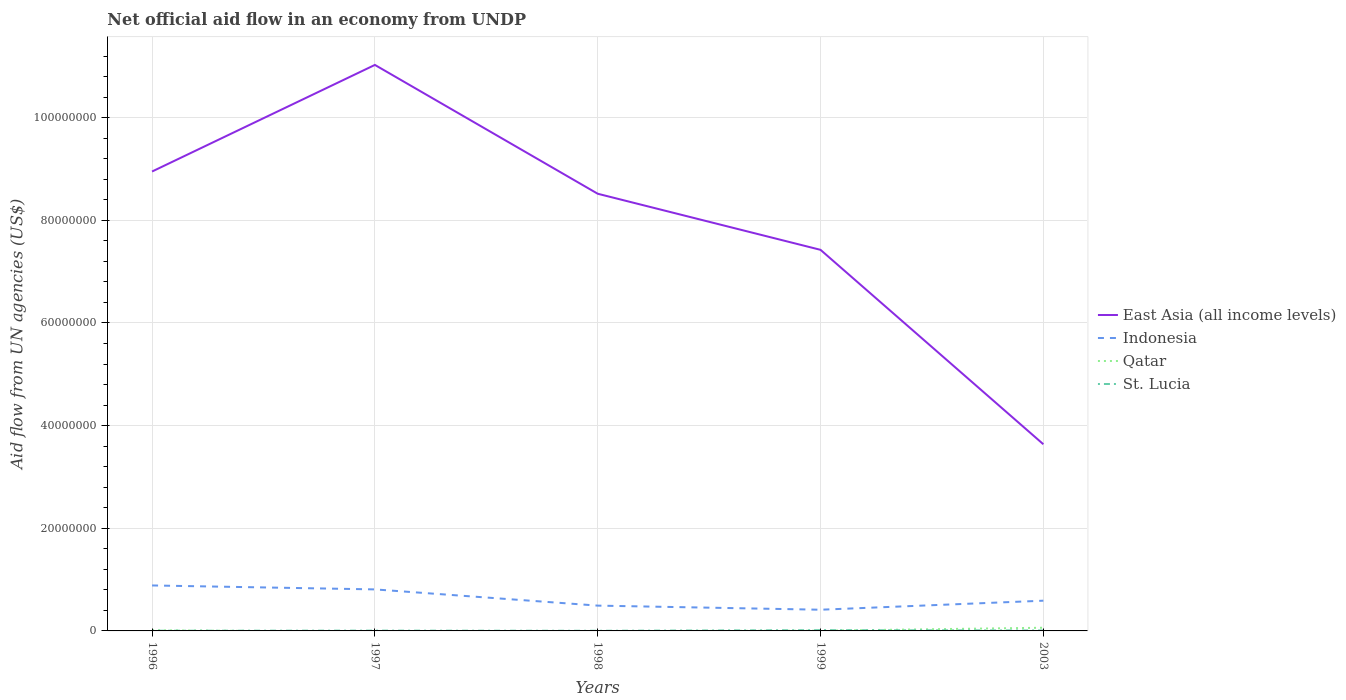Is the number of lines equal to the number of legend labels?
Provide a succinct answer. No. Across all years, what is the maximum net official aid flow in East Asia (all income levels)?
Give a very brief answer. 3.64e+07. What is the total net official aid flow in St. Lucia in the graph?
Offer a very short reply. 10000. What is the difference between the highest and the second highest net official aid flow in Qatar?
Keep it short and to the point. 6.20e+05. What is the difference between the highest and the lowest net official aid flow in Qatar?
Provide a succinct answer. 1. Is the net official aid flow in Indonesia strictly greater than the net official aid flow in St. Lucia over the years?
Offer a terse response. No. How many years are there in the graph?
Your answer should be very brief. 5. What is the difference between two consecutive major ticks on the Y-axis?
Your answer should be compact. 2.00e+07. Does the graph contain any zero values?
Make the answer very short. Yes. Where does the legend appear in the graph?
Provide a short and direct response. Center right. What is the title of the graph?
Offer a terse response. Net official aid flow in an economy from UNDP. Does "New Zealand" appear as one of the legend labels in the graph?
Keep it short and to the point. No. What is the label or title of the Y-axis?
Provide a short and direct response. Aid flow from UN agencies (US$). What is the Aid flow from UN agencies (US$) of East Asia (all income levels) in 1996?
Offer a very short reply. 8.95e+07. What is the Aid flow from UN agencies (US$) of Indonesia in 1996?
Your answer should be compact. 8.86e+06. What is the Aid flow from UN agencies (US$) of Qatar in 1996?
Make the answer very short. 1.30e+05. What is the Aid flow from UN agencies (US$) in East Asia (all income levels) in 1997?
Provide a short and direct response. 1.10e+08. What is the Aid flow from UN agencies (US$) of Indonesia in 1997?
Provide a succinct answer. 8.09e+06. What is the Aid flow from UN agencies (US$) in St. Lucia in 1997?
Ensure brevity in your answer.  6.00e+04. What is the Aid flow from UN agencies (US$) in East Asia (all income levels) in 1998?
Your answer should be compact. 8.52e+07. What is the Aid flow from UN agencies (US$) in Indonesia in 1998?
Give a very brief answer. 4.93e+06. What is the Aid flow from UN agencies (US$) of Qatar in 1998?
Your answer should be very brief. 0. What is the Aid flow from UN agencies (US$) of St. Lucia in 1998?
Your answer should be compact. 3.00e+04. What is the Aid flow from UN agencies (US$) in East Asia (all income levels) in 1999?
Make the answer very short. 7.42e+07. What is the Aid flow from UN agencies (US$) in Indonesia in 1999?
Offer a terse response. 4.13e+06. What is the Aid flow from UN agencies (US$) in St. Lucia in 1999?
Your response must be concise. 1.50e+05. What is the Aid flow from UN agencies (US$) of East Asia (all income levels) in 2003?
Provide a succinct answer. 3.64e+07. What is the Aid flow from UN agencies (US$) of Indonesia in 2003?
Ensure brevity in your answer.  5.89e+06. What is the Aid flow from UN agencies (US$) in Qatar in 2003?
Provide a short and direct response. 6.20e+05. Across all years, what is the maximum Aid flow from UN agencies (US$) in East Asia (all income levels)?
Offer a terse response. 1.10e+08. Across all years, what is the maximum Aid flow from UN agencies (US$) of Indonesia?
Ensure brevity in your answer.  8.86e+06. Across all years, what is the maximum Aid flow from UN agencies (US$) in Qatar?
Keep it short and to the point. 6.20e+05. Across all years, what is the minimum Aid flow from UN agencies (US$) of East Asia (all income levels)?
Your response must be concise. 3.64e+07. Across all years, what is the minimum Aid flow from UN agencies (US$) in Indonesia?
Your response must be concise. 4.13e+06. Across all years, what is the minimum Aid flow from UN agencies (US$) in St. Lucia?
Provide a short and direct response. 3.00e+04. What is the total Aid flow from UN agencies (US$) of East Asia (all income levels) in the graph?
Your answer should be compact. 3.96e+08. What is the total Aid flow from UN agencies (US$) in Indonesia in the graph?
Offer a terse response. 3.19e+07. What is the total Aid flow from UN agencies (US$) of Qatar in the graph?
Your response must be concise. 7.90e+05. What is the difference between the Aid flow from UN agencies (US$) in East Asia (all income levels) in 1996 and that in 1997?
Your response must be concise. -2.08e+07. What is the difference between the Aid flow from UN agencies (US$) in Indonesia in 1996 and that in 1997?
Your answer should be very brief. 7.70e+05. What is the difference between the Aid flow from UN agencies (US$) in East Asia (all income levels) in 1996 and that in 1998?
Your answer should be very brief. 4.33e+06. What is the difference between the Aid flow from UN agencies (US$) in Indonesia in 1996 and that in 1998?
Your answer should be compact. 3.93e+06. What is the difference between the Aid flow from UN agencies (US$) of St. Lucia in 1996 and that in 1998?
Ensure brevity in your answer.  10000. What is the difference between the Aid flow from UN agencies (US$) of East Asia (all income levels) in 1996 and that in 1999?
Your answer should be compact. 1.53e+07. What is the difference between the Aid flow from UN agencies (US$) of Indonesia in 1996 and that in 1999?
Provide a short and direct response. 4.73e+06. What is the difference between the Aid flow from UN agencies (US$) in St. Lucia in 1996 and that in 1999?
Your response must be concise. -1.10e+05. What is the difference between the Aid flow from UN agencies (US$) of East Asia (all income levels) in 1996 and that in 2003?
Your response must be concise. 5.31e+07. What is the difference between the Aid flow from UN agencies (US$) of Indonesia in 1996 and that in 2003?
Ensure brevity in your answer.  2.97e+06. What is the difference between the Aid flow from UN agencies (US$) of Qatar in 1996 and that in 2003?
Provide a short and direct response. -4.90e+05. What is the difference between the Aid flow from UN agencies (US$) of East Asia (all income levels) in 1997 and that in 1998?
Offer a terse response. 2.51e+07. What is the difference between the Aid flow from UN agencies (US$) in Indonesia in 1997 and that in 1998?
Your response must be concise. 3.16e+06. What is the difference between the Aid flow from UN agencies (US$) of St. Lucia in 1997 and that in 1998?
Keep it short and to the point. 3.00e+04. What is the difference between the Aid flow from UN agencies (US$) in East Asia (all income levels) in 1997 and that in 1999?
Keep it short and to the point. 3.60e+07. What is the difference between the Aid flow from UN agencies (US$) of Indonesia in 1997 and that in 1999?
Offer a terse response. 3.96e+06. What is the difference between the Aid flow from UN agencies (US$) of East Asia (all income levels) in 1997 and that in 2003?
Give a very brief answer. 7.39e+07. What is the difference between the Aid flow from UN agencies (US$) in Indonesia in 1997 and that in 2003?
Give a very brief answer. 2.20e+06. What is the difference between the Aid flow from UN agencies (US$) in St. Lucia in 1997 and that in 2003?
Your answer should be compact. -3.00e+04. What is the difference between the Aid flow from UN agencies (US$) of East Asia (all income levels) in 1998 and that in 1999?
Provide a succinct answer. 1.09e+07. What is the difference between the Aid flow from UN agencies (US$) of East Asia (all income levels) in 1998 and that in 2003?
Your answer should be compact. 4.88e+07. What is the difference between the Aid flow from UN agencies (US$) in Indonesia in 1998 and that in 2003?
Make the answer very short. -9.60e+05. What is the difference between the Aid flow from UN agencies (US$) of St. Lucia in 1998 and that in 2003?
Your answer should be very brief. -6.00e+04. What is the difference between the Aid flow from UN agencies (US$) in East Asia (all income levels) in 1999 and that in 2003?
Your answer should be very brief. 3.79e+07. What is the difference between the Aid flow from UN agencies (US$) of Indonesia in 1999 and that in 2003?
Your response must be concise. -1.76e+06. What is the difference between the Aid flow from UN agencies (US$) of Qatar in 1999 and that in 2003?
Offer a terse response. -5.80e+05. What is the difference between the Aid flow from UN agencies (US$) of St. Lucia in 1999 and that in 2003?
Provide a succinct answer. 6.00e+04. What is the difference between the Aid flow from UN agencies (US$) of East Asia (all income levels) in 1996 and the Aid flow from UN agencies (US$) of Indonesia in 1997?
Offer a very short reply. 8.14e+07. What is the difference between the Aid flow from UN agencies (US$) in East Asia (all income levels) in 1996 and the Aid flow from UN agencies (US$) in St. Lucia in 1997?
Offer a very short reply. 8.94e+07. What is the difference between the Aid flow from UN agencies (US$) of Indonesia in 1996 and the Aid flow from UN agencies (US$) of St. Lucia in 1997?
Make the answer very short. 8.80e+06. What is the difference between the Aid flow from UN agencies (US$) in Qatar in 1996 and the Aid flow from UN agencies (US$) in St. Lucia in 1997?
Provide a short and direct response. 7.00e+04. What is the difference between the Aid flow from UN agencies (US$) of East Asia (all income levels) in 1996 and the Aid flow from UN agencies (US$) of Indonesia in 1998?
Ensure brevity in your answer.  8.46e+07. What is the difference between the Aid flow from UN agencies (US$) in East Asia (all income levels) in 1996 and the Aid flow from UN agencies (US$) in St. Lucia in 1998?
Keep it short and to the point. 8.95e+07. What is the difference between the Aid flow from UN agencies (US$) of Indonesia in 1996 and the Aid flow from UN agencies (US$) of St. Lucia in 1998?
Make the answer very short. 8.83e+06. What is the difference between the Aid flow from UN agencies (US$) of Qatar in 1996 and the Aid flow from UN agencies (US$) of St. Lucia in 1998?
Offer a terse response. 1.00e+05. What is the difference between the Aid flow from UN agencies (US$) in East Asia (all income levels) in 1996 and the Aid flow from UN agencies (US$) in Indonesia in 1999?
Your answer should be compact. 8.54e+07. What is the difference between the Aid flow from UN agencies (US$) of East Asia (all income levels) in 1996 and the Aid flow from UN agencies (US$) of Qatar in 1999?
Your answer should be compact. 8.95e+07. What is the difference between the Aid flow from UN agencies (US$) in East Asia (all income levels) in 1996 and the Aid flow from UN agencies (US$) in St. Lucia in 1999?
Give a very brief answer. 8.94e+07. What is the difference between the Aid flow from UN agencies (US$) of Indonesia in 1996 and the Aid flow from UN agencies (US$) of Qatar in 1999?
Ensure brevity in your answer.  8.82e+06. What is the difference between the Aid flow from UN agencies (US$) of Indonesia in 1996 and the Aid flow from UN agencies (US$) of St. Lucia in 1999?
Make the answer very short. 8.71e+06. What is the difference between the Aid flow from UN agencies (US$) of East Asia (all income levels) in 1996 and the Aid flow from UN agencies (US$) of Indonesia in 2003?
Provide a short and direct response. 8.36e+07. What is the difference between the Aid flow from UN agencies (US$) of East Asia (all income levels) in 1996 and the Aid flow from UN agencies (US$) of Qatar in 2003?
Your answer should be very brief. 8.89e+07. What is the difference between the Aid flow from UN agencies (US$) of East Asia (all income levels) in 1996 and the Aid flow from UN agencies (US$) of St. Lucia in 2003?
Provide a short and direct response. 8.94e+07. What is the difference between the Aid flow from UN agencies (US$) in Indonesia in 1996 and the Aid flow from UN agencies (US$) in Qatar in 2003?
Your answer should be compact. 8.24e+06. What is the difference between the Aid flow from UN agencies (US$) in Indonesia in 1996 and the Aid flow from UN agencies (US$) in St. Lucia in 2003?
Your response must be concise. 8.77e+06. What is the difference between the Aid flow from UN agencies (US$) in Qatar in 1996 and the Aid flow from UN agencies (US$) in St. Lucia in 2003?
Offer a very short reply. 4.00e+04. What is the difference between the Aid flow from UN agencies (US$) of East Asia (all income levels) in 1997 and the Aid flow from UN agencies (US$) of Indonesia in 1998?
Provide a short and direct response. 1.05e+08. What is the difference between the Aid flow from UN agencies (US$) in East Asia (all income levels) in 1997 and the Aid flow from UN agencies (US$) in St. Lucia in 1998?
Provide a succinct answer. 1.10e+08. What is the difference between the Aid flow from UN agencies (US$) in Indonesia in 1997 and the Aid flow from UN agencies (US$) in St. Lucia in 1998?
Offer a very short reply. 8.06e+06. What is the difference between the Aid flow from UN agencies (US$) of East Asia (all income levels) in 1997 and the Aid flow from UN agencies (US$) of Indonesia in 1999?
Offer a very short reply. 1.06e+08. What is the difference between the Aid flow from UN agencies (US$) of East Asia (all income levels) in 1997 and the Aid flow from UN agencies (US$) of Qatar in 1999?
Your answer should be very brief. 1.10e+08. What is the difference between the Aid flow from UN agencies (US$) in East Asia (all income levels) in 1997 and the Aid flow from UN agencies (US$) in St. Lucia in 1999?
Your answer should be compact. 1.10e+08. What is the difference between the Aid flow from UN agencies (US$) in Indonesia in 1997 and the Aid flow from UN agencies (US$) in Qatar in 1999?
Offer a very short reply. 8.05e+06. What is the difference between the Aid flow from UN agencies (US$) of Indonesia in 1997 and the Aid flow from UN agencies (US$) of St. Lucia in 1999?
Provide a short and direct response. 7.94e+06. What is the difference between the Aid flow from UN agencies (US$) of East Asia (all income levels) in 1997 and the Aid flow from UN agencies (US$) of Indonesia in 2003?
Make the answer very short. 1.04e+08. What is the difference between the Aid flow from UN agencies (US$) of East Asia (all income levels) in 1997 and the Aid flow from UN agencies (US$) of Qatar in 2003?
Provide a succinct answer. 1.10e+08. What is the difference between the Aid flow from UN agencies (US$) of East Asia (all income levels) in 1997 and the Aid flow from UN agencies (US$) of St. Lucia in 2003?
Your answer should be very brief. 1.10e+08. What is the difference between the Aid flow from UN agencies (US$) in Indonesia in 1997 and the Aid flow from UN agencies (US$) in Qatar in 2003?
Provide a succinct answer. 7.47e+06. What is the difference between the Aid flow from UN agencies (US$) of Indonesia in 1997 and the Aid flow from UN agencies (US$) of St. Lucia in 2003?
Make the answer very short. 8.00e+06. What is the difference between the Aid flow from UN agencies (US$) of East Asia (all income levels) in 1998 and the Aid flow from UN agencies (US$) of Indonesia in 1999?
Offer a terse response. 8.10e+07. What is the difference between the Aid flow from UN agencies (US$) in East Asia (all income levels) in 1998 and the Aid flow from UN agencies (US$) in Qatar in 1999?
Keep it short and to the point. 8.51e+07. What is the difference between the Aid flow from UN agencies (US$) of East Asia (all income levels) in 1998 and the Aid flow from UN agencies (US$) of St. Lucia in 1999?
Provide a short and direct response. 8.50e+07. What is the difference between the Aid flow from UN agencies (US$) of Indonesia in 1998 and the Aid flow from UN agencies (US$) of Qatar in 1999?
Give a very brief answer. 4.89e+06. What is the difference between the Aid flow from UN agencies (US$) in Indonesia in 1998 and the Aid flow from UN agencies (US$) in St. Lucia in 1999?
Give a very brief answer. 4.78e+06. What is the difference between the Aid flow from UN agencies (US$) of East Asia (all income levels) in 1998 and the Aid flow from UN agencies (US$) of Indonesia in 2003?
Provide a short and direct response. 7.93e+07. What is the difference between the Aid flow from UN agencies (US$) of East Asia (all income levels) in 1998 and the Aid flow from UN agencies (US$) of Qatar in 2003?
Your answer should be compact. 8.46e+07. What is the difference between the Aid flow from UN agencies (US$) in East Asia (all income levels) in 1998 and the Aid flow from UN agencies (US$) in St. Lucia in 2003?
Make the answer very short. 8.51e+07. What is the difference between the Aid flow from UN agencies (US$) in Indonesia in 1998 and the Aid flow from UN agencies (US$) in Qatar in 2003?
Your answer should be very brief. 4.31e+06. What is the difference between the Aid flow from UN agencies (US$) of Indonesia in 1998 and the Aid flow from UN agencies (US$) of St. Lucia in 2003?
Your answer should be compact. 4.84e+06. What is the difference between the Aid flow from UN agencies (US$) in East Asia (all income levels) in 1999 and the Aid flow from UN agencies (US$) in Indonesia in 2003?
Your answer should be very brief. 6.84e+07. What is the difference between the Aid flow from UN agencies (US$) in East Asia (all income levels) in 1999 and the Aid flow from UN agencies (US$) in Qatar in 2003?
Keep it short and to the point. 7.36e+07. What is the difference between the Aid flow from UN agencies (US$) of East Asia (all income levels) in 1999 and the Aid flow from UN agencies (US$) of St. Lucia in 2003?
Give a very brief answer. 7.42e+07. What is the difference between the Aid flow from UN agencies (US$) in Indonesia in 1999 and the Aid flow from UN agencies (US$) in Qatar in 2003?
Offer a very short reply. 3.51e+06. What is the difference between the Aid flow from UN agencies (US$) of Indonesia in 1999 and the Aid flow from UN agencies (US$) of St. Lucia in 2003?
Ensure brevity in your answer.  4.04e+06. What is the average Aid flow from UN agencies (US$) in East Asia (all income levels) per year?
Provide a succinct answer. 7.91e+07. What is the average Aid flow from UN agencies (US$) of Indonesia per year?
Ensure brevity in your answer.  6.38e+06. What is the average Aid flow from UN agencies (US$) of Qatar per year?
Your answer should be very brief. 1.58e+05. What is the average Aid flow from UN agencies (US$) of St. Lucia per year?
Your response must be concise. 7.40e+04. In the year 1996, what is the difference between the Aid flow from UN agencies (US$) in East Asia (all income levels) and Aid flow from UN agencies (US$) in Indonesia?
Give a very brief answer. 8.06e+07. In the year 1996, what is the difference between the Aid flow from UN agencies (US$) of East Asia (all income levels) and Aid flow from UN agencies (US$) of Qatar?
Provide a succinct answer. 8.94e+07. In the year 1996, what is the difference between the Aid flow from UN agencies (US$) of East Asia (all income levels) and Aid flow from UN agencies (US$) of St. Lucia?
Give a very brief answer. 8.95e+07. In the year 1996, what is the difference between the Aid flow from UN agencies (US$) of Indonesia and Aid flow from UN agencies (US$) of Qatar?
Give a very brief answer. 8.73e+06. In the year 1996, what is the difference between the Aid flow from UN agencies (US$) of Indonesia and Aid flow from UN agencies (US$) of St. Lucia?
Ensure brevity in your answer.  8.82e+06. In the year 1997, what is the difference between the Aid flow from UN agencies (US$) in East Asia (all income levels) and Aid flow from UN agencies (US$) in Indonesia?
Your answer should be very brief. 1.02e+08. In the year 1997, what is the difference between the Aid flow from UN agencies (US$) in East Asia (all income levels) and Aid flow from UN agencies (US$) in St. Lucia?
Your response must be concise. 1.10e+08. In the year 1997, what is the difference between the Aid flow from UN agencies (US$) in Indonesia and Aid flow from UN agencies (US$) in St. Lucia?
Provide a short and direct response. 8.03e+06. In the year 1998, what is the difference between the Aid flow from UN agencies (US$) of East Asia (all income levels) and Aid flow from UN agencies (US$) of Indonesia?
Provide a short and direct response. 8.02e+07. In the year 1998, what is the difference between the Aid flow from UN agencies (US$) in East Asia (all income levels) and Aid flow from UN agencies (US$) in St. Lucia?
Provide a succinct answer. 8.52e+07. In the year 1998, what is the difference between the Aid flow from UN agencies (US$) of Indonesia and Aid flow from UN agencies (US$) of St. Lucia?
Your response must be concise. 4.90e+06. In the year 1999, what is the difference between the Aid flow from UN agencies (US$) in East Asia (all income levels) and Aid flow from UN agencies (US$) in Indonesia?
Keep it short and to the point. 7.01e+07. In the year 1999, what is the difference between the Aid flow from UN agencies (US$) in East Asia (all income levels) and Aid flow from UN agencies (US$) in Qatar?
Provide a succinct answer. 7.42e+07. In the year 1999, what is the difference between the Aid flow from UN agencies (US$) of East Asia (all income levels) and Aid flow from UN agencies (US$) of St. Lucia?
Provide a short and direct response. 7.41e+07. In the year 1999, what is the difference between the Aid flow from UN agencies (US$) in Indonesia and Aid flow from UN agencies (US$) in Qatar?
Keep it short and to the point. 4.09e+06. In the year 1999, what is the difference between the Aid flow from UN agencies (US$) of Indonesia and Aid flow from UN agencies (US$) of St. Lucia?
Ensure brevity in your answer.  3.98e+06. In the year 1999, what is the difference between the Aid flow from UN agencies (US$) in Qatar and Aid flow from UN agencies (US$) in St. Lucia?
Make the answer very short. -1.10e+05. In the year 2003, what is the difference between the Aid flow from UN agencies (US$) of East Asia (all income levels) and Aid flow from UN agencies (US$) of Indonesia?
Your answer should be compact. 3.05e+07. In the year 2003, what is the difference between the Aid flow from UN agencies (US$) of East Asia (all income levels) and Aid flow from UN agencies (US$) of Qatar?
Provide a succinct answer. 3.58e+07. In the year 2003, what is the difference between the Aid flow from UN agencies (US$) of East Asia (all income levels) and Aid flow from UN agencies (US$) of St. Lucia?
Offer a terse response. 3.63e+07. In the year 2003, what is the difference between the Aid flow from UN agencies (US$) in Indonesia and Aid flow from UN agencies (US$) in Qatar?
Make the answer very short. 5.27e+06. In the year 2003, what is the difference between the Aid flow from UN agencies (US$) in Indonesia and Aid flow from UN agencies (US$) in St. Lucia?
Provide a short and direct response. 5.80e+06. In the year 2003, what is the difference between the Aid flow from UN agencies (US$) of Qatar and Aid flow from UN agencies (US$) of St. Lucia?
Offer a terse response. 5.30e+05. What is the ratio of the Aid flow from UN agencies (US$) of East Asia (all income levels) in 1996 to that in 1997?
Make the answer very short. 0.81. What is the ratio of the Aid flow from UN agencies (US$) in Indonesia in 1996 to that in 1997?
Your response must be concise. 1.1. What is the ratio of the Aid flow from UN agencies (US$) of East Asia (all income levels) in 1996 to that in 1998?
Offer a very short reply. 1.05. What is the ratio of the Aid flow from UN agencies (US$) in Indonesia in 1996 to that in 1998?
Make the answer very short. 1.8. What is the ratio of the Aid flow from UN agencies (US$) of East Asia (all income levels) in 1996 to that in 1999?
Ensure brevity in your answer.  1.21. What is the ratio of the Aid flow from UN agencies (US$) in Indonesia in 1996 to that in 1999?
Give a very brief answer. 2.15. What is the ratio of the Aid flow from UN agencies (US$) in Qatar in 1996 to that in 1999?
Ensure brevity in your answer.  3.25. What is the ratio of the Aid flow from UN agencies (US$) in St. Lucia in 1996 to that in 1999?
Your response must be concise. 0.27. What is the ratio of the Aid flow from UN agencies (US$) in East Asia (all income levels) in 1996 to that in 2003?
Offer a very short reply. 2.46. What is the ratio of the Aid flow from UN agencies (US$) of Indonesia in 1996 to that in 2003?
Your answer should be very brief. 1.5. What is the ratio of the Aid flow from UN agencies (US$) of Qatar in 1996 to that in 2003?
Keep it short and to the point. 0.21. What is the ratio of the Aid flow from UN agencies (US$) of St. Lucia in 1996 to that in 2003?
Provide a succinct answer. 0.44. What is the ratio of the Aid flow from UN agencies (US$) of East Asia (all income levels) in 1997 to that in 1998?
Your answer should be very brief. 1.29. What is the ratio of the Aid flow from UN agencies (US$) of Indonesia in 1997 to that in 1998?
Your answer should be compact. 1.64. What is the ratio of the Aid flow from UN agencies (US$) in St. Lucia in 1997 to that in 1998?
Your answer should be compact. 2. What is the ratio of the Aid flow from UN agencies (US$) in East Asia (all income levels) in 1997 to that in 1999?
Make the answer very short. 1.49. What is the ratio of the Aid flow from UN agencies (US$) in Indonesia in 1997 to that in 1999?
Provide a succinct answer. 1.96. What is the ratio of the Aid flow from UN agencies (US$) of St. Lucia in 1997 to that in 1999?
Your answer should be very brief. 0.4. What is the ratio of the Aid flow from UN agencies (US$) of East Asia (all income levels) in 1997 to that in 2003?
Give a very brief answer. 3.03. What is the ratio of the Aid flow from UN agencies (US$) of Indonesia in 1997 to that in 2003?
Give a very brief answer. 1.37. What is the ratio of the Aid flow from UN agencies (US$) in East Asia (all income levels) in 1998 to that in 1999?
Your response must be concise. 1.15. What is the ratio of the Aid flow from UN agencies (US$) of Indonesia in 1998 to that in 1999?
Offer a terse response. 1.19. What is the ratio of the Aid flow from UN agencies (US$) of St. Lucia in 1998 to that in 1999?
Provide a short and direct response. 0.2. What is the ratio of the Aid flow from UN agencies (US$) in East Asia (all income levels) in 1998 to that in 2003?
Offer a terse response. 2.34. What is the ratio of the Aid flow from UN agencies (US$) in Indonesia in 1998 to that in 2003?
Provide a succinct answer. 0.84. What is the ratio of the Aid flow from UN agencies (US$) in East Asia (all income levels) in 1999 to that in 2003?
Provide a short and direct response. 2.04. What is the ratio of the Aid flow from UN agencies (US$) of Indonesia in 1999 to that in 2003?
Give a very brief answer. 0.7. What is the ratio of the Aid flow from UN agencies (US$) of Qatar in 1999 to that in 2003?
Provide a short and direct response. 0.06. What is the difference between the highest and the second highest Aid flow from UN agencies (US$) in East Asia (all income levels)?
Your answer should be very brief. 2.08e+07. What is the difference between the highest and the second highest Aid flow from UN agencies (US$) of Indonesia?
Make the answer very short. 7.70e+05. What is the difference between the highest and the lowest Aid flow from UN agencies (US$) of East Asia (all income levels)?
Your answer should be very brief. 7.39e+07. What is the difference between the highest and the lowest Aid flow from UN agencies (US$) in Indonesia?
Offer a very short reply. 4.73e+06. What is the difference between the highest and the lowest Aid flow from UN agencies (US$) in Qatar?
Make the answer very short. 6.20e+05. What is the difference between the highest and the lowest Aid flow from UN agencies (US$) of St. Lucia?
Offer a terse response. 1.20e+05. 